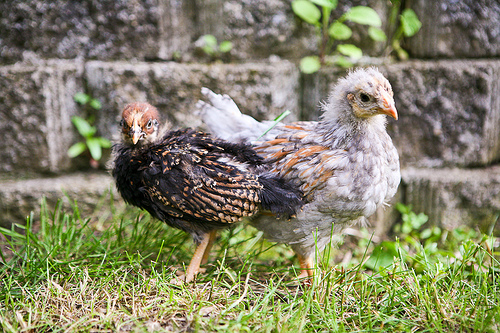<image>
Is there a weed above the animal? No. The weed is not positioned above the animal. The vertical arrangement shows a different relationship. 